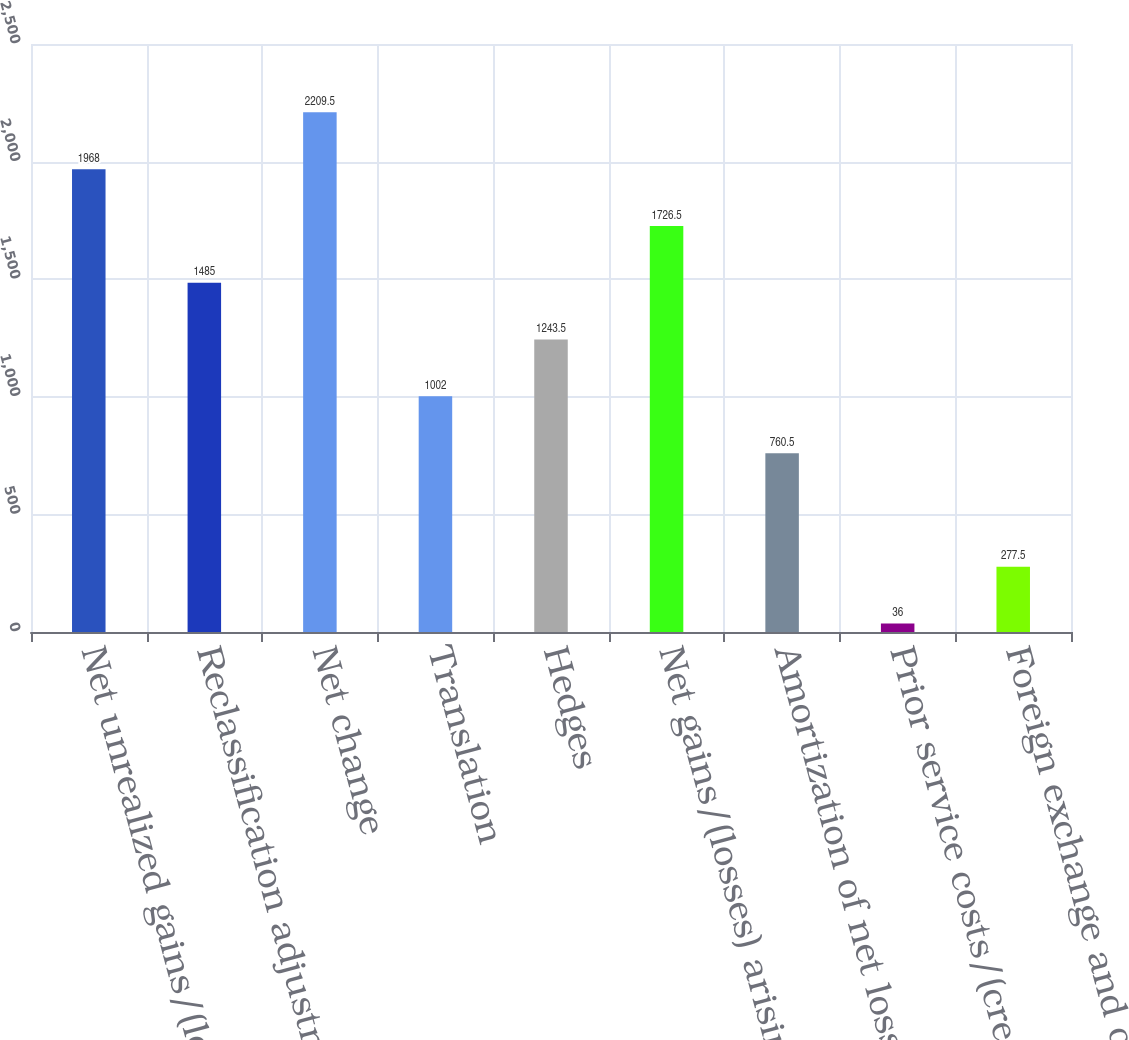Convert chart to OTSL. <chart><loc_0><loc_0><loc_500><loc_500><bar_chart><fcel>Net unrealized gains/(losses)<fcel>Reclassification adjustment<fcel>Net change<fcel>Translation<fcel>Hedges<fcel>Net gains/(losses) arising<fcel>Amortization of net loss<fcel>Prior service costs/(credits)<fcel>Foreign exchange and other<nl><fcel>1968<fcel>1485<fcel>2209.5<fcel>1002<fcel>1243.5<fcel>1726.5<fcel>760.5<fcel>36<fcel>277.5<nl></chart> 